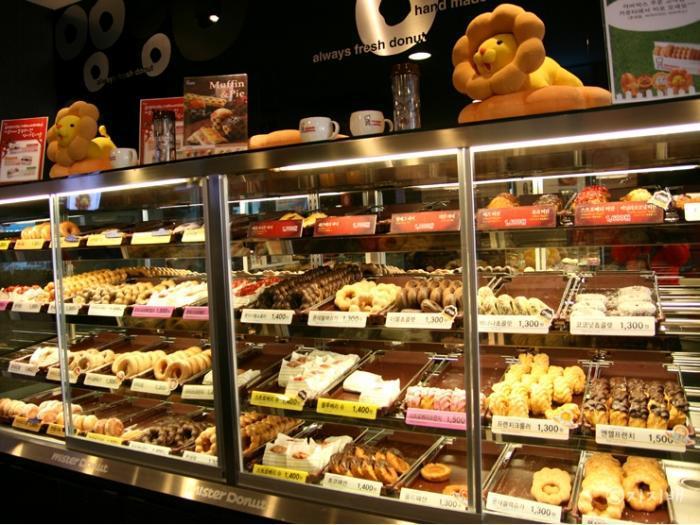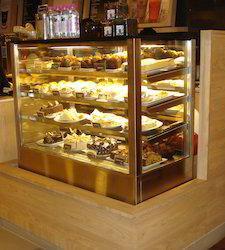The first image is the image on the left, the second image is the image on the right. For the images shown, is this caption "People are standing near a case of baked goods" true? Answer yes or no. No. The first image is the image on the left, the second image is the image on the right. Considering the images on both sides, is "At least five pendant lights hang over one of the bakery display images." valid? Answer yes or no. No. 